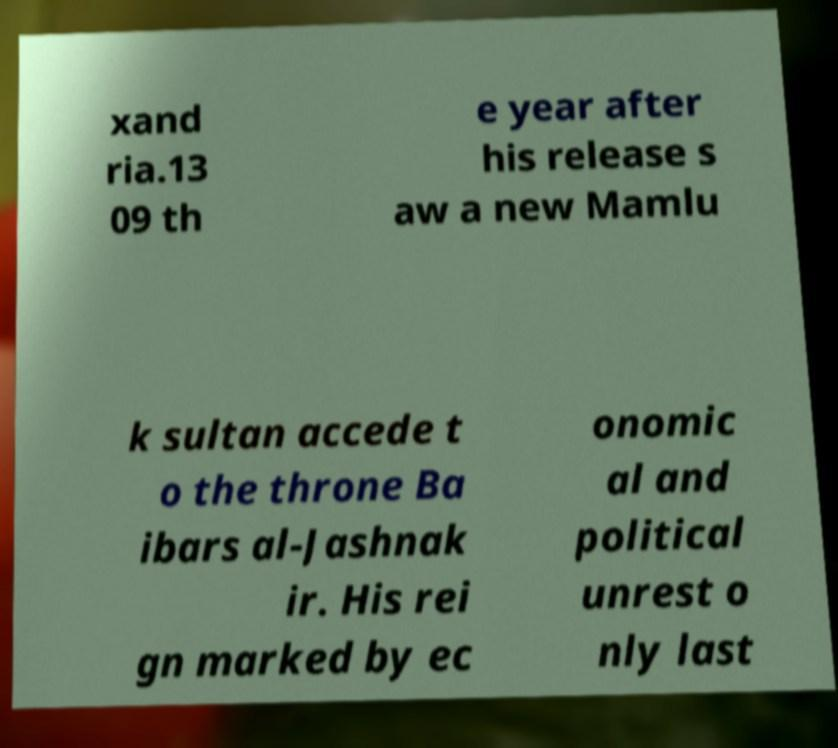Please read and relay the text visible in this image. What does it say? xand ria.13 09 th e year after his release s aw a new Mamlu k sultan accede t o the throne Ba ibars al-Jashnak ir. His rei gn marked by ec onomic al and political unrest o nly last 